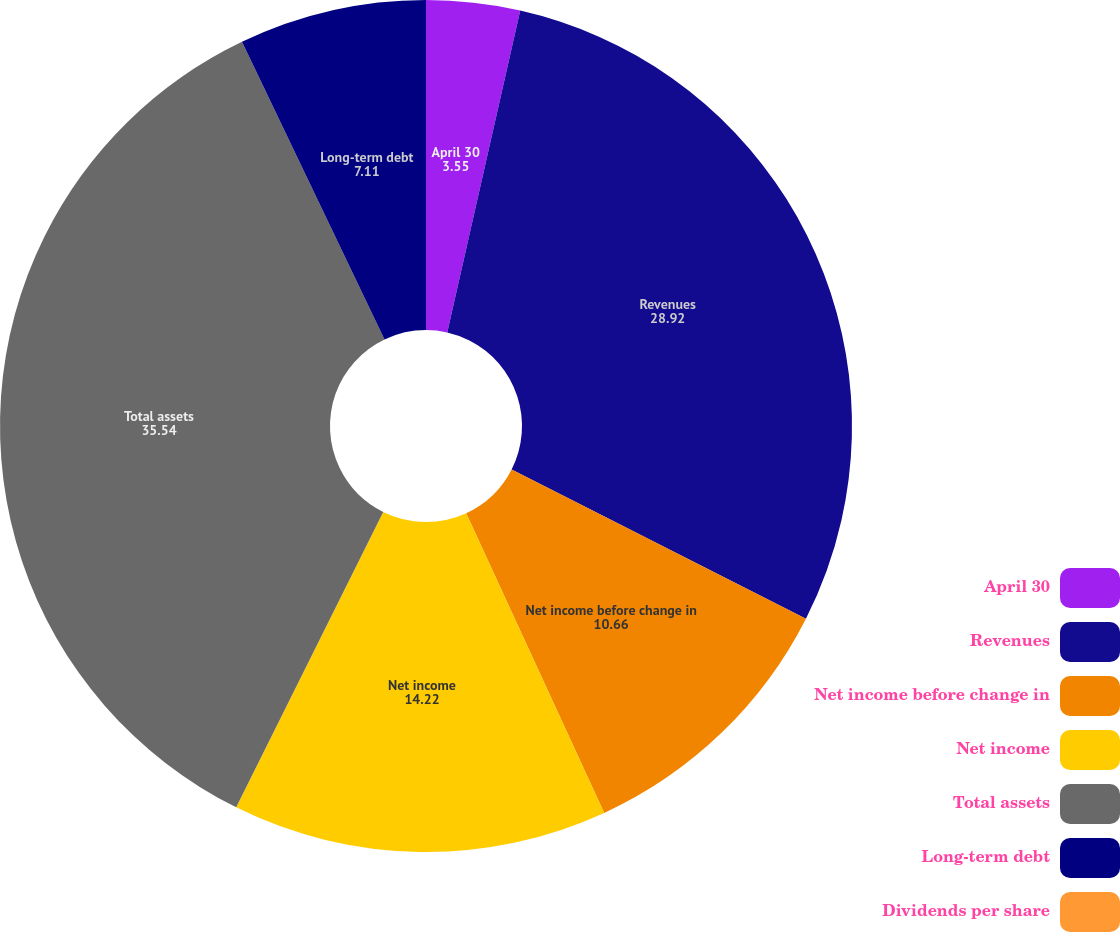<chart> <loc_0><loc_0><loc_500><loc_500><pie_chart><fcel>April 30<fcel>Revenues<fcel>Net income before change in<fcel>Net income<fcel>Total assets<fcel>Long-term debt<fcel>Dividends per share<nl><fcel>3.55%<fcel>28.92%<fcel>10.66%<fcel>14.22%<fcel>35.54%<fcel>7.11%<fcel>0.0%<nl></chart> 